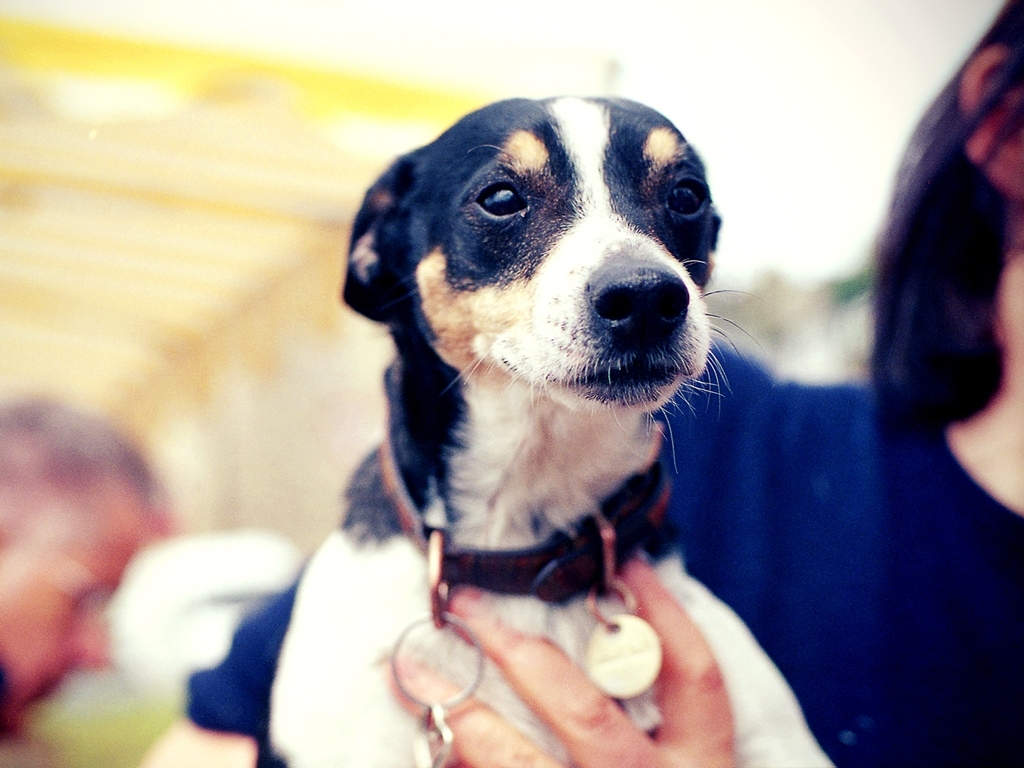What could be the reason for the dog's attentive expression? The dog's attentive look could be due to its focus on its owner, a nearby animal or object of interest, or a response to a sound or command. Is there anything in the image that suggests what it might be focused on? Nothing in the image explicitly indicates what the dog is focused on, as the immediate surroundings are out of focus and do not provide clear visual clues. 